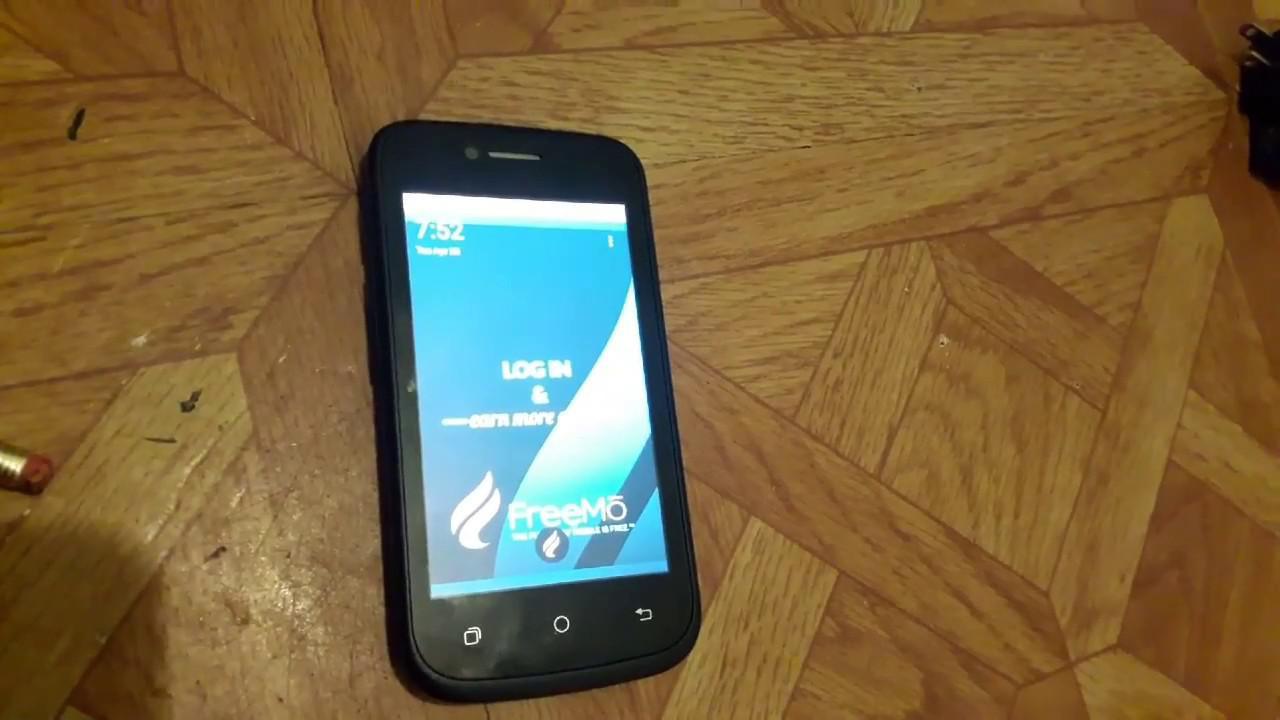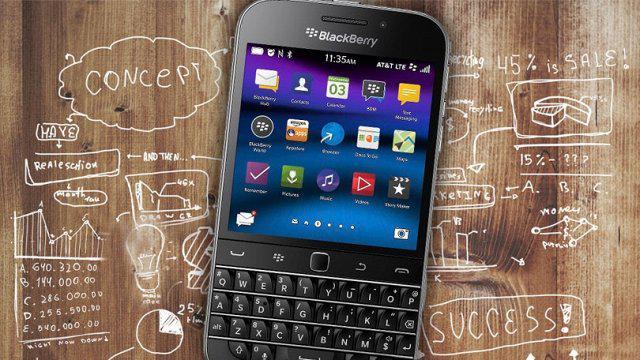The first image is the image on the left, the second image is the image on the right. Considering the images on both sides, is "The combined images include two hands, each holding a flat phone with a screen that nearly fills its front." valid? Answer yes or no. No. The first image is the image on the left, the second image is the image on the right. For the images displayed, is the sentence "A phone is being held by a person in each photo." factually correct? Answer yes or no. No. 